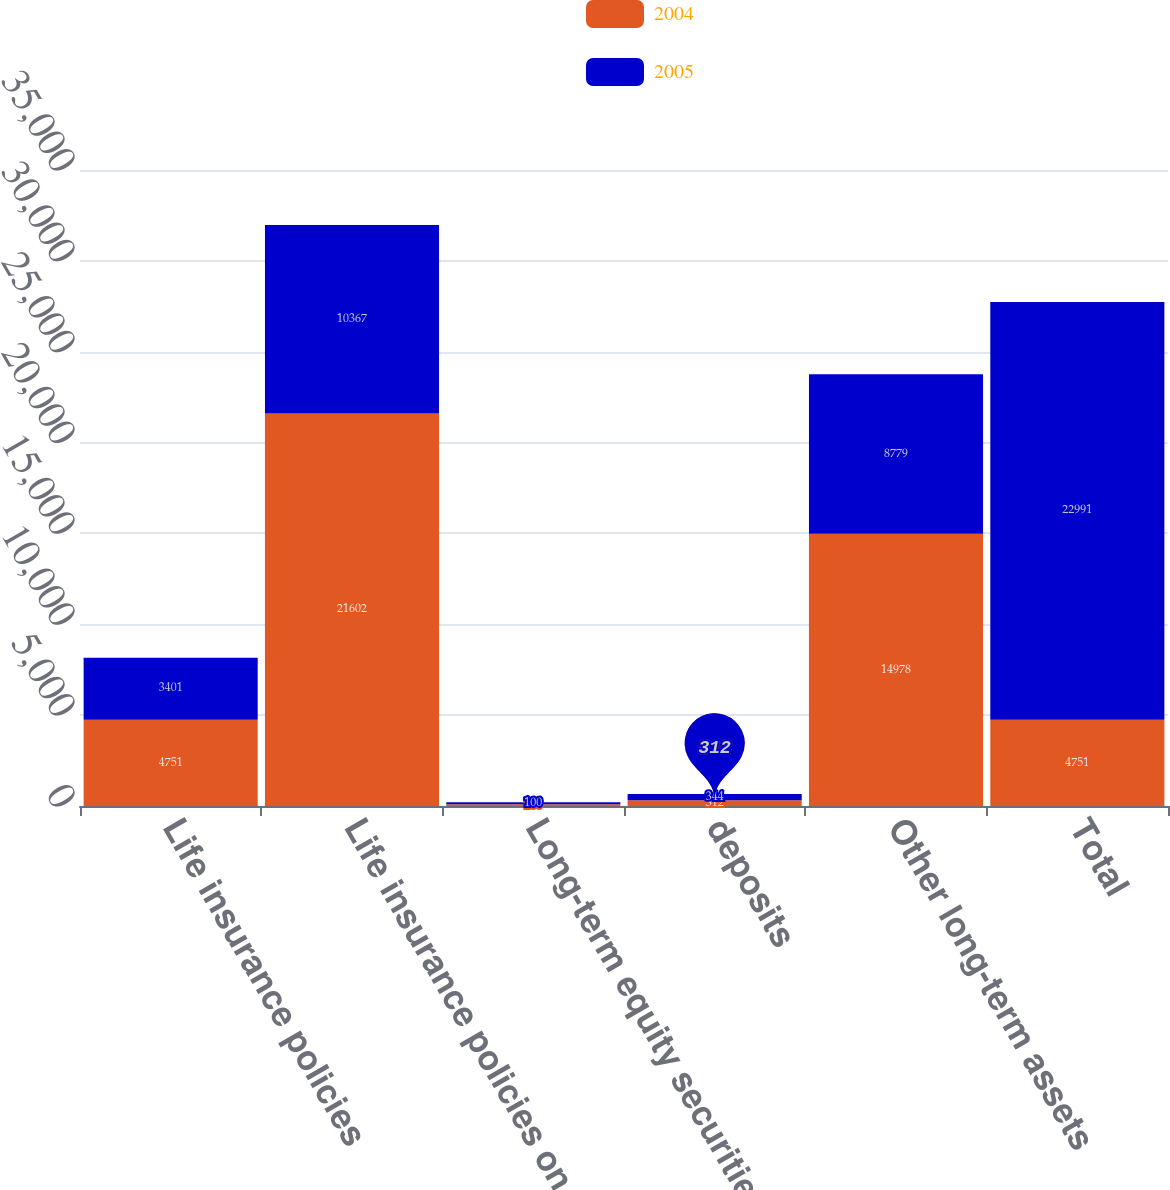Convert chart. <chart><loc_0><loc_0><loc_500><loc_500><stacked_bar_chart><ecel><fcel>Life insurance policies<fcel>Life insurance policies on key<fcel>Long-term equity securities<fcel>deposits<fcel>Other long-term assets<fcel>Total<nl><fcel>2004<fcel>4751<fcel>21602<fcel>100<fcel>312<fcel>14978<fcel>4751<nl><fcel>2005<fcel>3401<fcel>10367<fcel>100<fcel>344<fcel>8779<fcel>22991<nl></chart> 